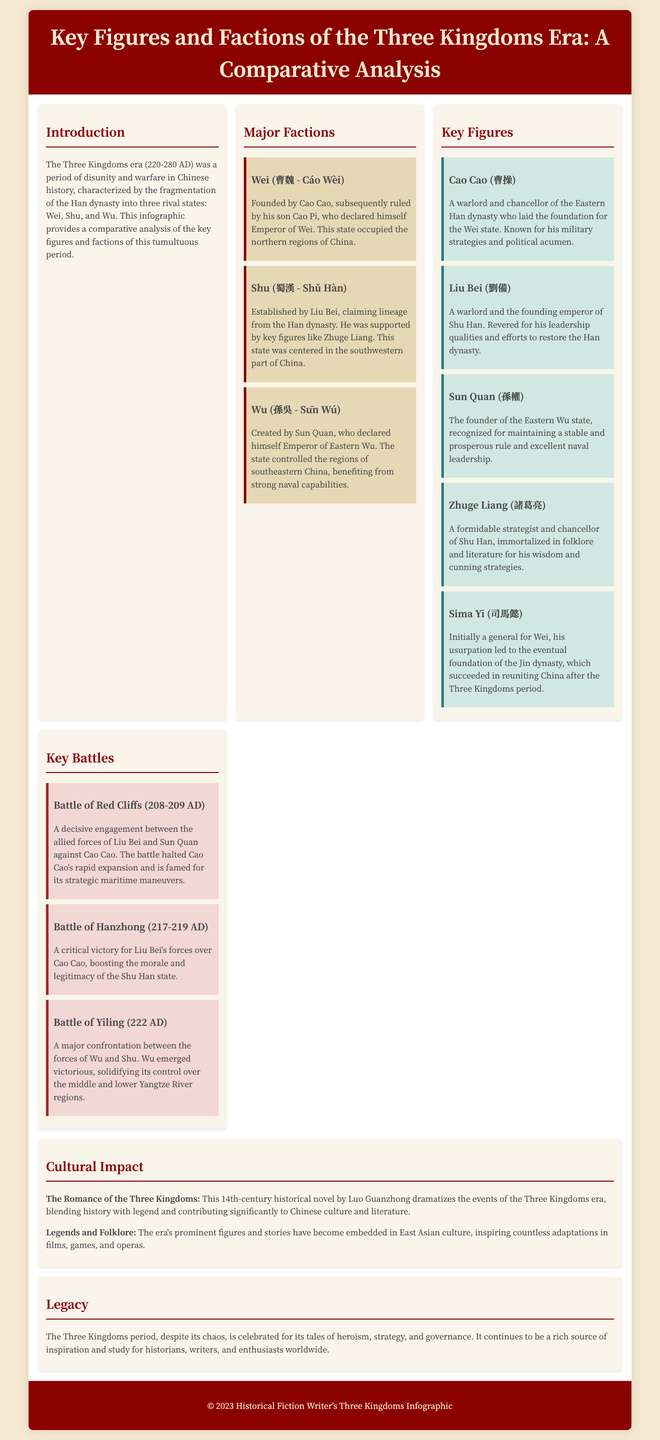What year did the Three Kingdoms era begin? The document states that the Three Kingdoms era started in 220 AD.
Answer: 220 AD Who founded the Wei state? The document mentions that Wei was founded by Cao Cao.
Answer: Cao Cao Which battle was a decisive engagement between Liu Bei and Sun Quan against Cao Cao? The document describes the Battle of Red Cliffs as the decisive engagement.
Answer: Battle of Red Cliffs How many states were involved in the Three Kingdoms era? The document highlights the fragmentation of the Han dynasty into three states: Wei, Shu, and Wu.
Answer: Three What is the key literary work associated with the Three Kingdoms era? The document references "The Romance of the Three Kingdoms" as a key literary work.
Answer: The Romance of the Three Kingdoms Which faction was ruled by Sun Quan? The document indicates that Sun Quan founded the Eastern Wu state.
Answer: Wu Who was the Chancellor of Shu Han? The document states that Zhuge Liang was the Chancellor of Shu Han.
Answer: Zhuge Liang What impact did the Three Kingdoms era have on culture? The document explains that the era has influenced legends and folklore in East Asian culture.
Answer: Legends and folklore Which key figure laid the foundation for the Wei state? The document identifies Cao Cao as the figure who laid the foundation for Wei.
Answer: Cao Cao 